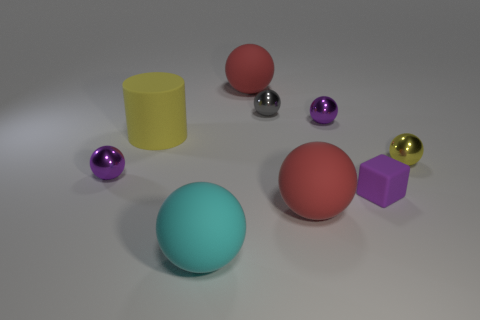Subtract all blue blocks. How many red balls are left? 2 Subtract all purple metallic spheres. How many spheres are left? 5 Subtract all cyan balls. How many balls are left? 6 Subtract 5 balls. How many balls are left? 2 Add 1 tiny cyan cylinders. How many objects exist? 10 Subtract all red spheres. Subtract all yellow cylinders. How many spheres are left? 5 Subtract all blocks. How many objects are left? 8 Subtract all big rubber balls. Subtract all big yellow objects. How many objects are left? 5 Add 3 yellow rubber cylinders. How many yellow rubber cylinders are left? 4 Add 7 cylinders. How many cylinders exist? 8 